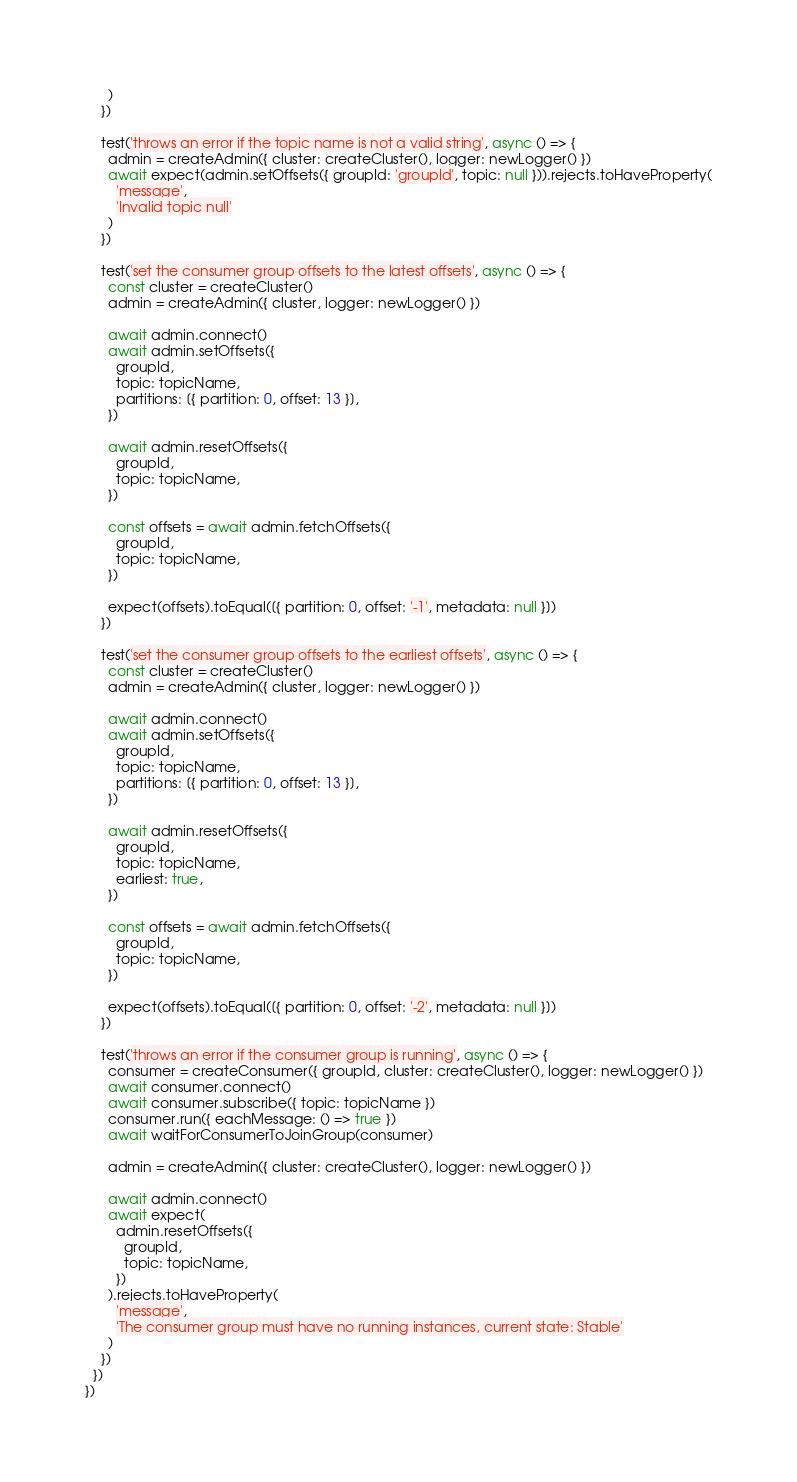Convert code to text. <code><loc_0><loc_0><loc_500><loc_500><_JavaScript_>      )
    })

    test('throws an error if the topic name is not a valid string', async () => {
      admin = createAdmin({ cluster: createCluster(), logger: newLogger() })
      await expect(admin.setOffsets({ groupId: 'groupId', topic: null })).rejects.toHaveProperty(
        'message',
        'Invalid topic null'
      )
    })

    test('set the consumer group offsets to the latest offsets', async () => {
      const cluster = createCluster()
      admin = createAdmin({ cluster, logger: newLogger() })

      await admin.connect()
      await admin.setOffsets({
        groupId,
        topic: topicName,
        partitions: [{ partition: 0, offset: 13 }],
      })

      await admin.resetOffsets({
        groupId,
        topic: topicName,
      })

      const offsets = await admin.fetchOffsets({
        groupId,
        topic: topicName,
      })

      expect(offsets).toEqual([{ partition: 0, offset: '-1', metadata: null }])
    })

    test('set the consumer group offsets to the earliest offsets', async () => {
      const cluster = createCluster()
      admin = createAdmin({ cluster, logger: newLogger() })

      await admin.connect()
      await admin.setOffsets({
        groupId,
        topic: topicName,
        partitions: [{ partition: 0, offset: 13 }],
      })

      await admin.resetOffsets({
        groupId,
        topic: topicName,
        earliest: true,
      })

      const offsets = await admin.fetchOffsets({
        groupId,
        topic: topicName,
      })

      expect(offsets).toEqual([{ partition: 0, offset: '-2', metadata: null }])
    })

    test('throws an error if the consumer group is running', async () => {
      consumer = createConsumer({ groupId, cluster: createCluster(), logger: newLogger() })
      await consumer.connect()
      await consumer.subscribe({ topic: topicName })
      consumer.run({ eachMessage: () => true })
      await waitForConsumerToJoinGroup(consumer)

      admin = createAdmin({ cluster: createCluster(), logger: newLogger() })

      await admin.connect()
      await expect(
        admin.resetOffsets({
          groupId,
          topic: topicName,
        })
      ).rejects.toHaveProperty(
        'message',
        'The consumer group must have no running instances, current state: Stable'
      )
    })
  })
})
</code> 